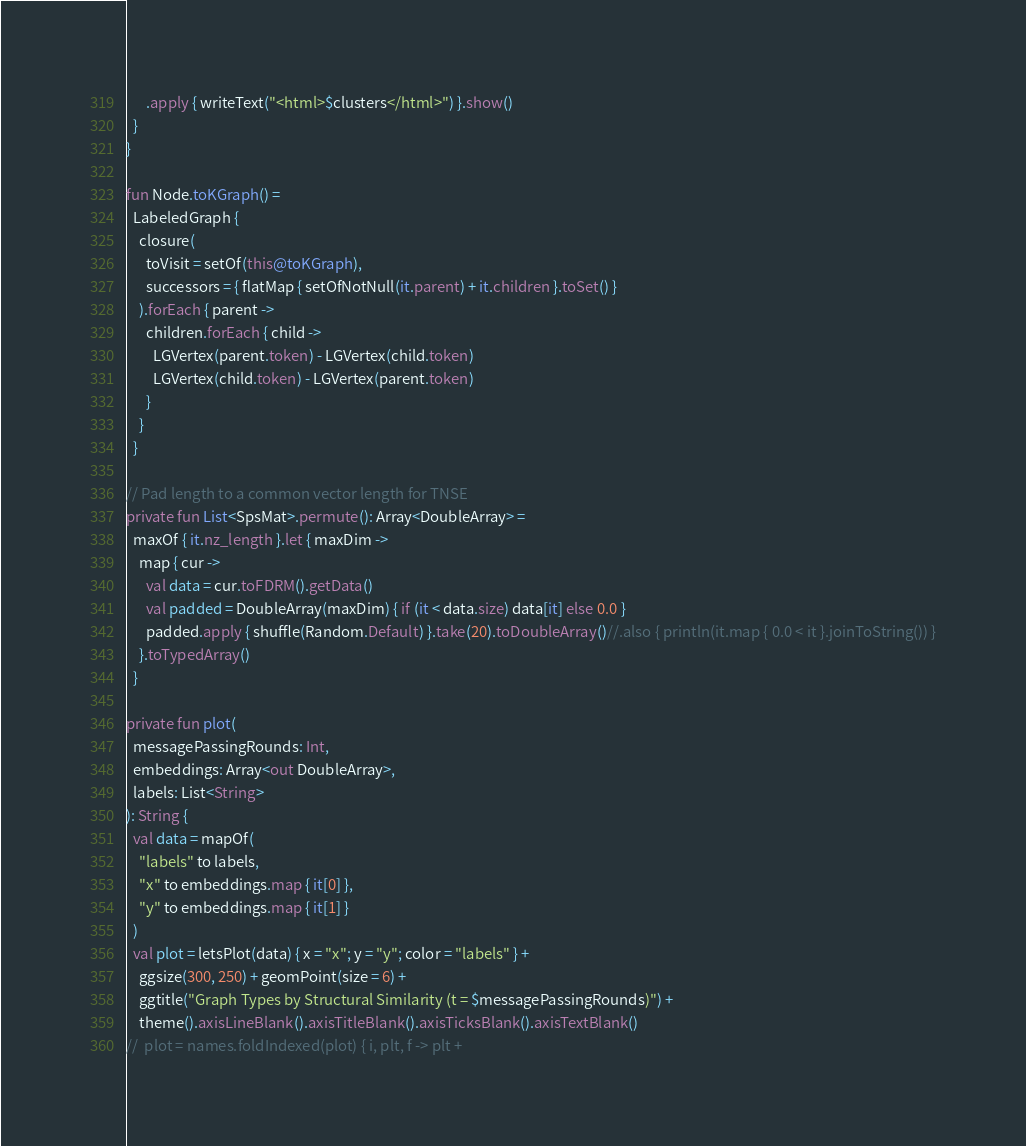Convert code to text. <code><loc_0><loc_0><loc_500><loc_500><_Kotlin_>      .apply { writeText("<html>$clusters</html>") }.show()
  }
}

fun Node.toKGraph() =
  LabeledGraph {
    closure(
      toVisit = setOf(this@toKGraph),
      successors = { flatMap { setOfNotNull(it.parent) + it.children }.toSet() }
    ).forEach { parent ->
      children.forEach { child ->
        LGVertex(parent.token) - LGVertex(child.token)
        LGVertex(child.token) - LGVertex(parent.token)
      }
    }
  }

// Pad length to a common vector length for TNSE
private fun List<SpsMat>.permute(): Array<DoubleArray> =
  maxOf { it.nz_length }.let { maxDim ->
    map { cur ->
      val data = cur.toFDRM().getData()
      val padded = DoubleArray(maxDim) { if (it < data.size) data[it] else 0.0 }
      padded.apply { shuffle(Random.Default) }.take(20).toDoubleArray()//.also { println(it.map { 0.0 < it }.joinToString()) }
    }.toTypedArray()
  }

private fun plot(
  messagePassingRounds: Int,
  embeddings: Array<out DoubleArray>,
  labels: List<String>
): String {
  val data = mapOf(
    "labels" to labels,
    "x" to embeddings.map { it[0] },
    "y" to embeddings.map { it[1] }
  )
  val plot = letsPlot(data) { x = "x"; y = "y"; color = "labels" } +
    ggsize(300, 250) + geomPoint(size = 6) +
    ggtitle("Graph Types by Structural Similarity (t = $messagePassingRounds)") +
    theme().axisLineBlank().axisTitleBlank().axisTicksBlank().axisTextBlank()
//  plot = names.foldIndexed(plot) { i, plt, f -> plt +</code> 